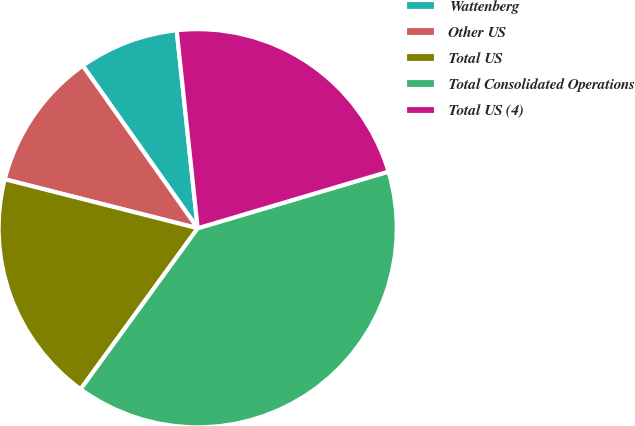Convert chart. <chart><loc_0><loc_0><loc_500><loc_500><pie_chart><fcel>Wattenberg<fcel>Other US<fcel>Total US<fcel>Total Consolidated Operations<fcel>Total US (4)<nl><fcel>8.11%<fcel>11.25%<fcel>18.95%<fcel>39.6%<fcel>22.09%<nl></chart> 